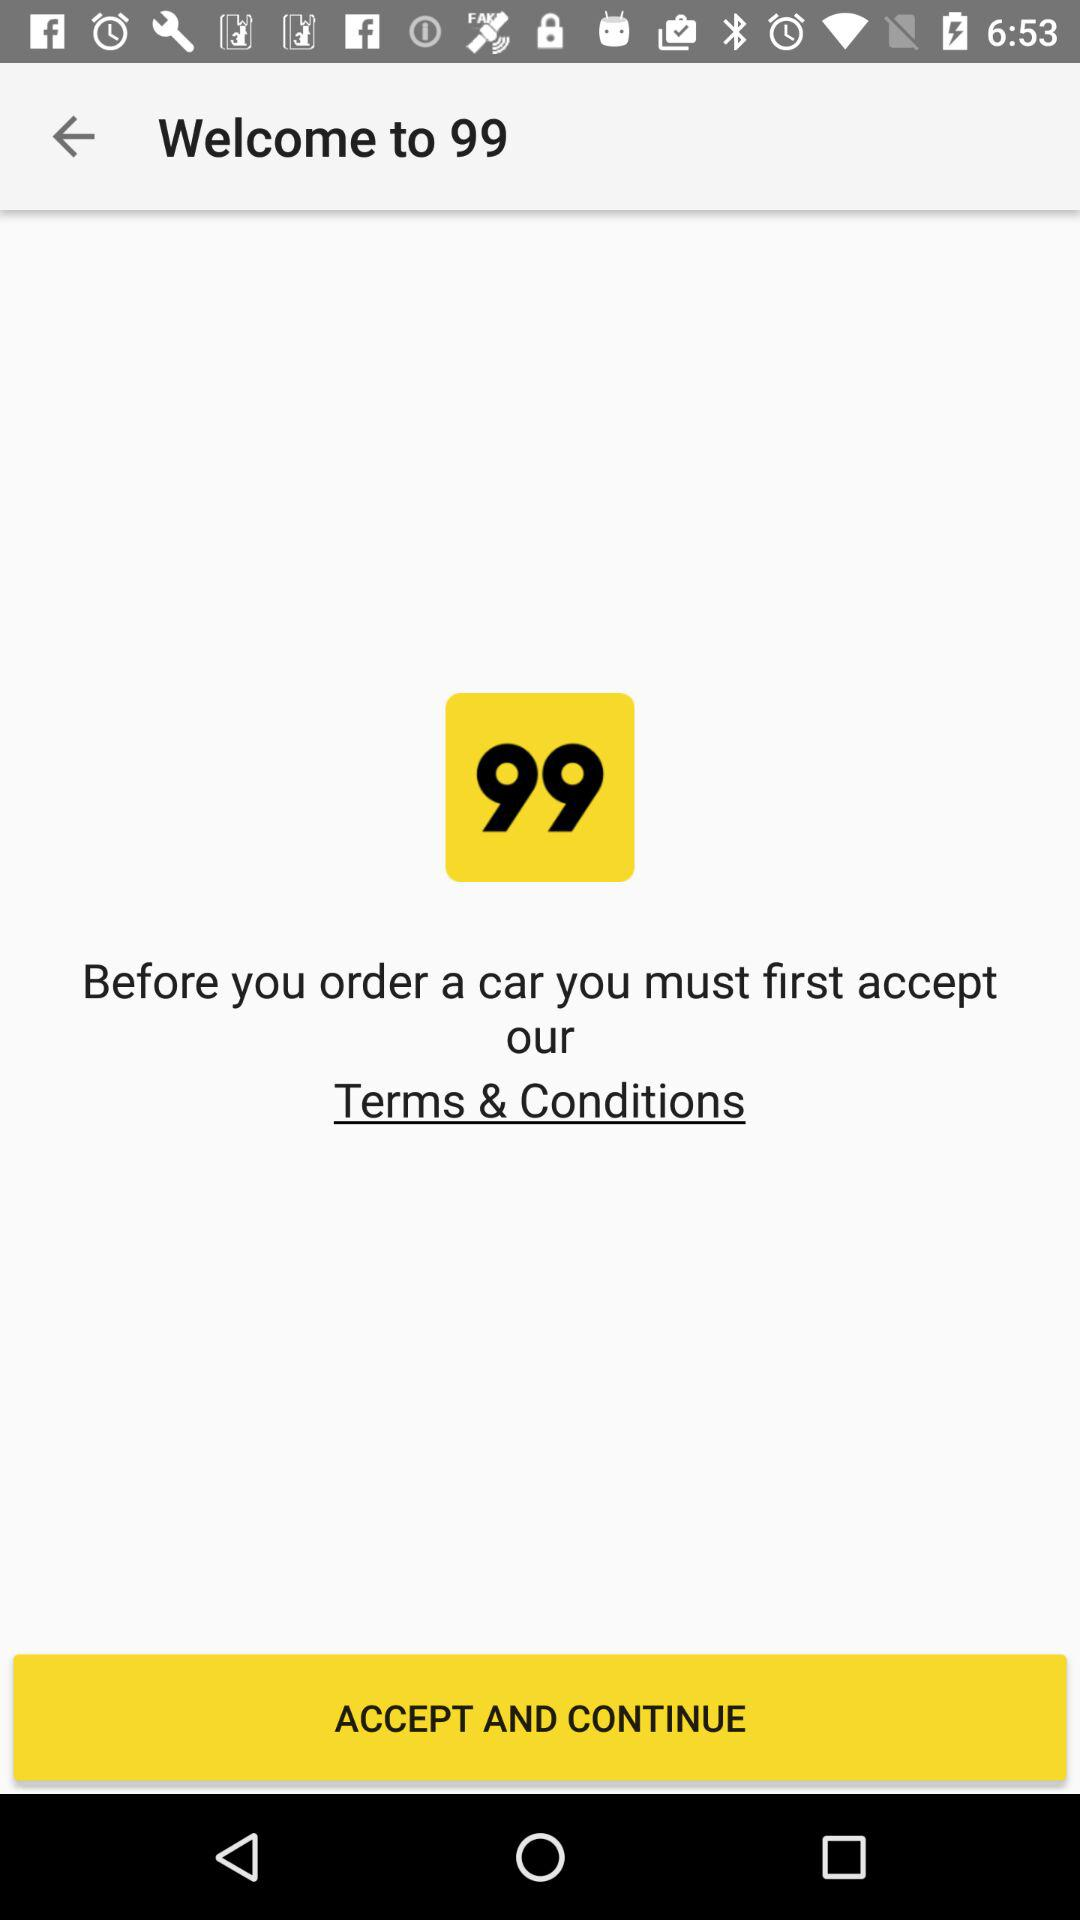What is the name of the application? The name of the application is "99". 